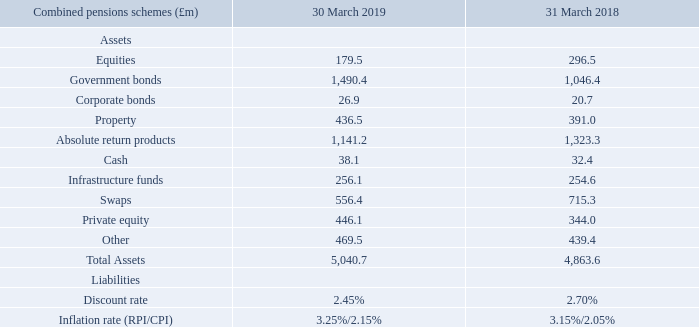Assets in the combined schemes increased by £177.1m to £5,040.7m in the period. RHM scheme assets increased by £149.1m to £4,333.6m while the Premier Foods’ schemes assets increased by £28.0m to £707.1m. The most significant movement by asset class is that of government bonds which increased by £444.0m in the year, predominantly in the RHM scheme.
Liabilities in the combined schemes increased by £121.0m in the year to £4,667.6m. The value of liabilities associated with the RHM scheme were £3,495.8m, an increase of £65.3m while liabilities in the Premier Foods schemes were £55.7m higher at £1,171.8m. The increase in the value of liabilities in both schemes is due to a lower discount rate assumption of 2.45% (31 March 2018: 2.70%) and an increase in the RPI inflation rate assumption; from 3.15% to 3.25%.
The Group’s Pension Trustees have just commenced the triennial actuarial valuation process of the Group’s pension schemes as at 31 March 2019 (RHM scheme) and 5 April 2019 (Premier Foods main scheme). This exercise typically takes a number of months to conclude; the output of which will be provided in due course.
The net present value of future deficit payments, to the end of the respective recovery periods remains at circa £300–320m.
What was the increase in the assets in the combined schemes in 2019? £177.1m. What was the increase in the liabilities in the combined schemes in 2019? £121.0m. What was the net present value of future-deficit payments? £300–320m. What was the change in equities from 2018 to 2019?
Answer scale should be: million. 179.5 - 296.5
Answer: -117. What was the average government bonds for 2018 and 2019?
Answer scale should be: million. (1,490.4 + 1,046.4) / 2
Answer: 1268.4. What was the change in the corporate bonds from 2018 to 2019?
Answer scale should be: million. 26.9 - 20.7
Answer: 6.2. 